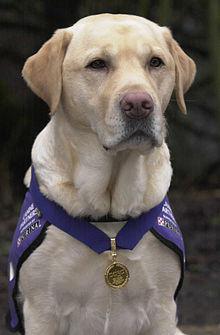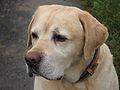The first image is the image on the left, the second image is the image on the right. For the images displayed, is the sentence "There are exactly 2 dogs in the left image." factually correct? Answer yes or no. No. The first image is the image on the left, the second image is the image on the right. Analyze the images presented: Is the assertion "There is at least 1 black and 1 white dog near some grass." valid? Answer yes or no. No. 